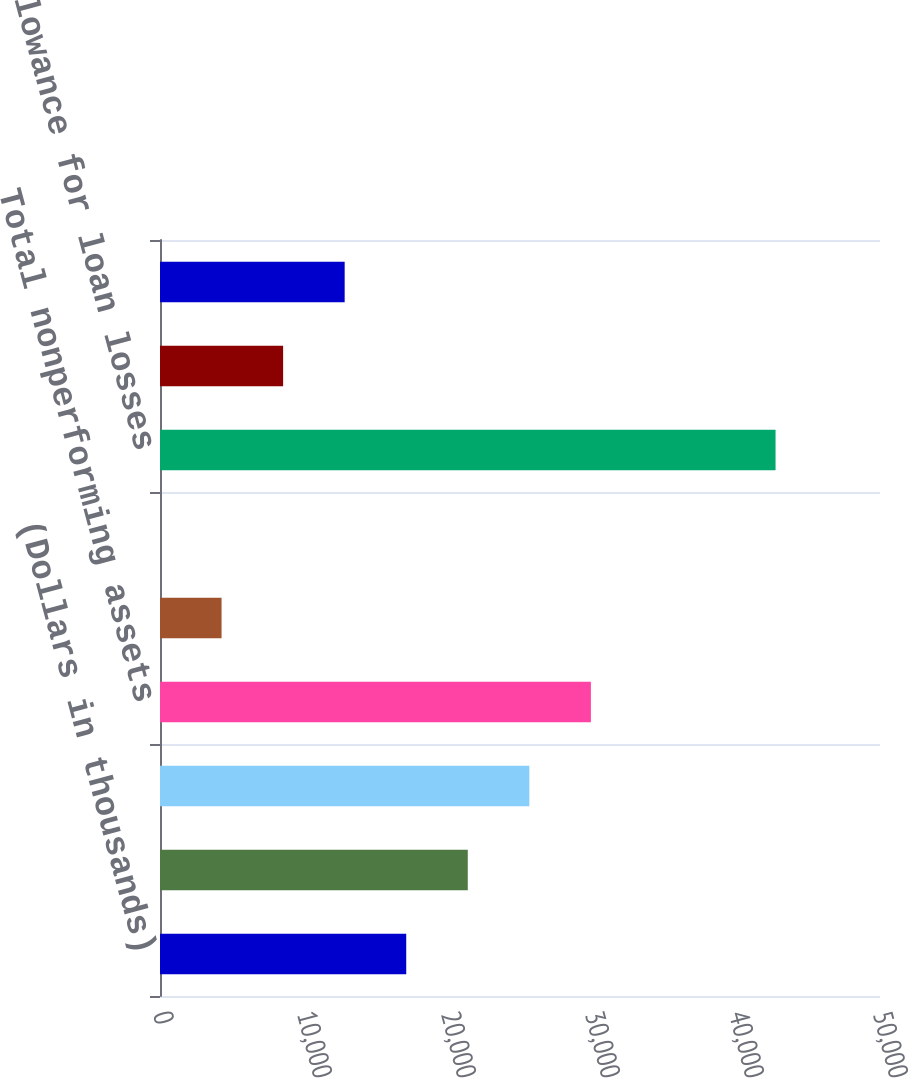Convert chart to OTSL. <chart><loc_0><loc_0><loc_500><loc_500><bar_chart><fcel>(Dollars in thousands)<fcel>Nonaccrual loans<fcel>Total nonperforming loans<fcel>Total nonperforming assets<fcel>Nonperforming loans as a<fcel>Nonperforming assets as a<fcel>Allowance for loan losses<fcel>As a percent of total gross<fcel>As a percent of nonaccrual<nl><fcel>17099<fcel>21373.6<fcel>25648.3<fcel>29923<fcel>4274.94<fcel>0.27<fcel>42747<fcel>8549.61<fcel>12824.3<nl></chart> 